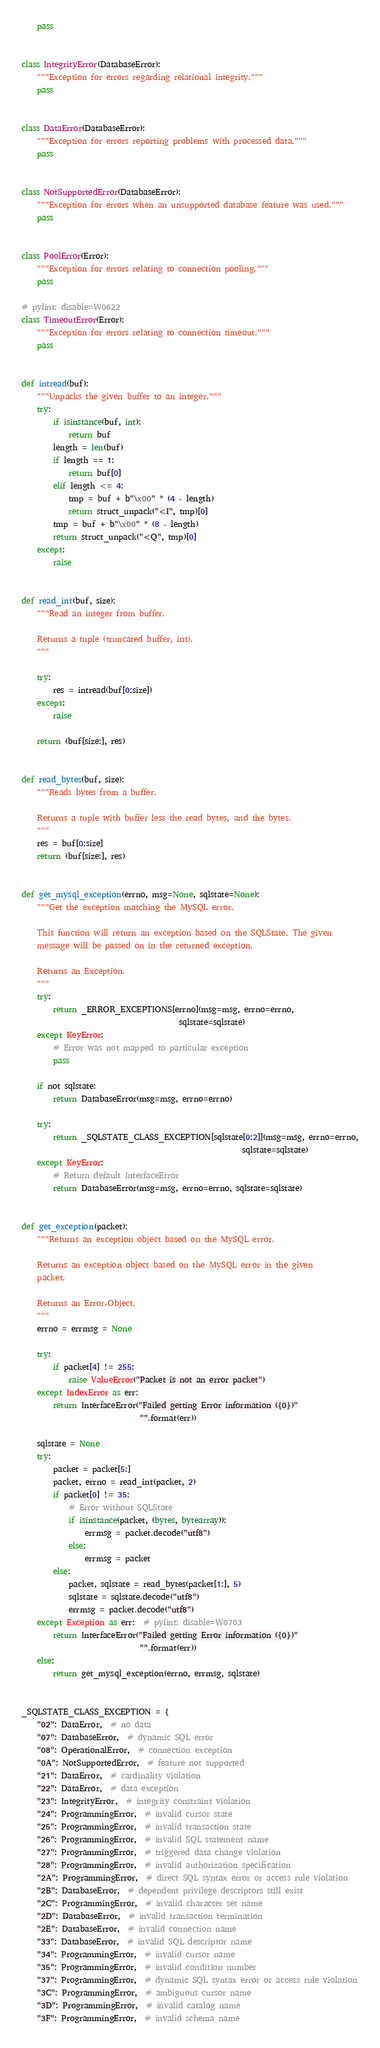<code> <loc_0><loc_0><loc_500><loc_500><_Python_>    pass


class IntegrityError(DatabaseError):
    """Exception for errors regarding relational integrity."""
    pass


class DataError(DatabaseError):
    """Exception for errors reporting problems with processed data."""
    pass


class NotSupportedError(DatabaseError):
    """Exception for errors when an unsupported database feature was used."""
    pass


class PoolError(Error):
    """Exception for errors relating to connection pooling."""
    pass

# pylint: disable=W0622
class TimeoutError(Error):
    """Exception for errors relating to connection timeout."""
    pass


def intread(buf):
    """Unpacks the given buffer to an integer."""
    try:
        if isinstance(buf, int):
            return buf
        length = len(buf)
        if length == 1:
            return buf[0]
        elif length <= 4:
            tmp = buf + b"\x00" * (4 - length)
            return struct_unpack("<I", tmp)[0]
        tmp = buf + b"\x00" * (8 - length)
        return struct_unpack("<Q", tmp)[0]
    except:
        raise


def read_int(buf, size):
    """Read an integer from buffer.

    Returns a tuple (truncated buffer, int).
    """

    try:
        res = intread(buf[0:size])
    except:
        raise

    return (buf[size:], res)


def read_bytes(buf, size):
    """Reads bytes from a buffer.

    Returns a tuple with buffer less the read bytes, and the bytes.
    """
    res = buf[0:size]
    return (buf[size:], res)


def get_mysql_exception(errno, msg=None, sqlstate=None):
    """Get the exception matching the MySQL error.

    This function will return an exception based on the SQLState. The given
    message will be passed on in the returned exception.

    Returns an Exception.
    """
    try:
        return _ERROR_EXCEPTIONS[errno](msg=msg, errno=errno,
                                        sqlstate=sqlstate)
    except KeyError:
        # Error was not mapped to particular exception
        pass

    if not sqlstate:
        return DatabaseError(msg=msg, errno=errno)

    try:
        return _SQLSTATE_CLASS_EXCEPTION[sqlstate[0:2]](msg=msg, errno=errno,
                                                        sqlstate=sqlstate)
    except KeyError:
        # Return default InterfaceError
        return DatabaseError(msg=msg, errno=errno, sqlstate=sqlstate)


def get_exception(packet):
    """Returns an exception object based on the MySQL error.

    Returns an exception object based on the MySQL error in the given
    packet.

    Returns an Error-Object.
    """
    errno = errmsg = None

    try:
        if packet[4] != 255:
            raise ValueError("Packet is not an error packet")
    except IndexError as err:
        return InterfaceError("Failed getting Error information ({0})"
                              "".format(err))

    sqlstate = None
    try:
        packet = packet[5:]
        packet, errno = read_int(packet, 2)
        if packet[0] != 35:
            # Error without SQLState
            if isinstance(packet, (bytes, bytearray)):
                errmsg = packet.decode("utf8")
            else:
                errmsg = packet
        else:
            packet, sqlstate = read_bytes(packet[1:], 5)
            sqlstate = sqlstate.decode("utf8")
            errmsg = packet.decode("utf8")
    except Exception as err:  # pylint: disable=W0703
        return InterfaceError("Failed getting Error information ({0})"
                              "".format(err))
    else:
        return get_mysql_exception(errno, errmsg, sqlstate)


_SQLSTATE_CLASS_EXCEPTION = {
    "02": DataError,  # no data
    "07": DatabaseError,  # dynamic SQL error
    "08": OperationalError,  # connection exception
    "0A": NotSupportedError,  # feature not supported
    "21": DataError,  # cardinality violation
    "22": DataError,  # data exception
    "23": IntegrityError,  # integrity constraint violation
    "24": ProgrammingError,  # invalid cursor state
    "25": ProgrammingError,  # invalid transaction state
    "26": ProgrammingError,  # invalid SQL statement name
    "27": ProgrammingError,  # triggered data change violation
    "28": ProgrammingError,  # invalid authorization specification
    "2A": ProgrammingError,  # direct SQL syntax error or access rule violation
    "2B": DatabaseError,  # dependent privilege descriptors still exist
    "2C": ProgrammingError,  # invalid character set name
    "2D": DatabaseError,  # invalid transaction termination
    "2E": DatabaseError,  # invalid connection name
    "33": DatabaseError,  # invalid SQL descriptor name
    "34": ProgrammingError,  # invalid cursor name
    "35": ProgrammingError,  # invalid condition number
    "37": ProgrammingError,  # dynamic SQL syntax error or access rule violation
    "3C": ProgrammingError,  # ambiguous cursor name
    "3D": ProgrammingError,  # invalid catalog name
    "3F": ProgrammingError,  # invalid schema name</code> 